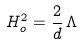<formula> <loc_0><loc_0><loc_500><loc_500>H _ { o } ^ { 2 } = \frac { 2 } { d } \, \Lambda</formula> 